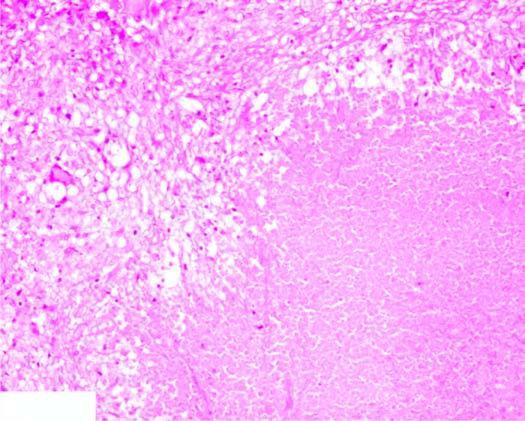what shows granulomatous inflammation?
Answer the question using a single word or phrase. The periphery 